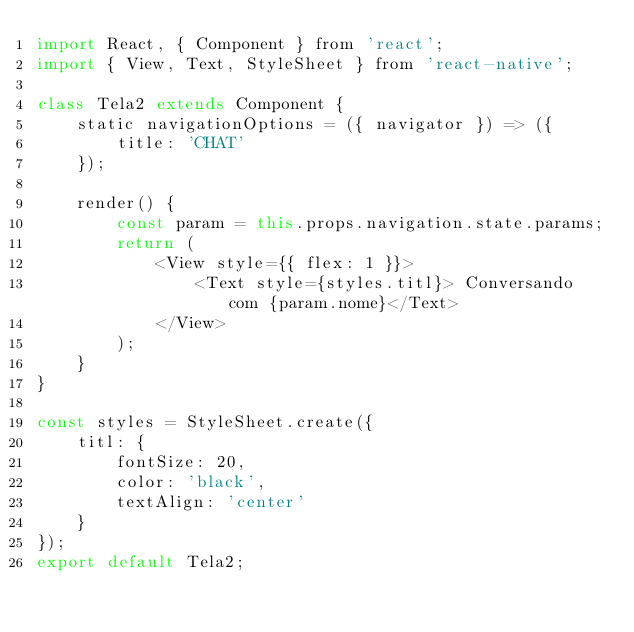Convert code to text. <code><loc_0><loc_0><loc_500><loc_500><_JavaScript_>import React, { Component } from 'react';
import { View, Text, StyleSheet } from 'react-native';

class Tela2 extends Component {
	static navigationOptions = ({ navigator }) => ({
		title: 'CHAT'
	});

	render() {
		const param = this.props.navigation.state.params;
		return (
			<View style={{ flex: 1 }}>
				<Text style={styles.titl}> Conversando com {param.nome}</Text>
			</View>
		);
	}
}

const styles = StyleSheet.create({
	titl: {
		fontSize: 20,
		color: 'black',
		textAlign: 'center'
	}
});
export default Tela2;</code> 